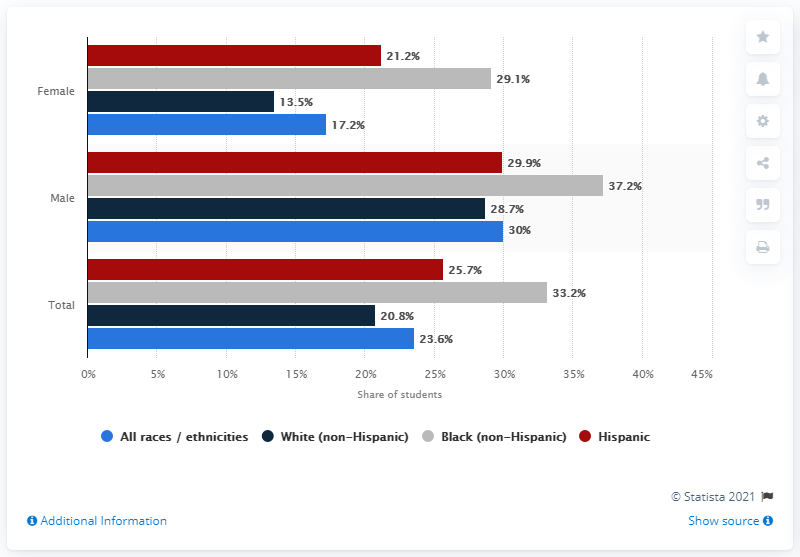Specify some key components in this picture. According to a recent study, 37.2% of male students with a black, non-Hispanic background reported having been involved in a physical fight at least once. The total value of all bars in the female category is 81. The value of the red bar in the male category is 29.9. 